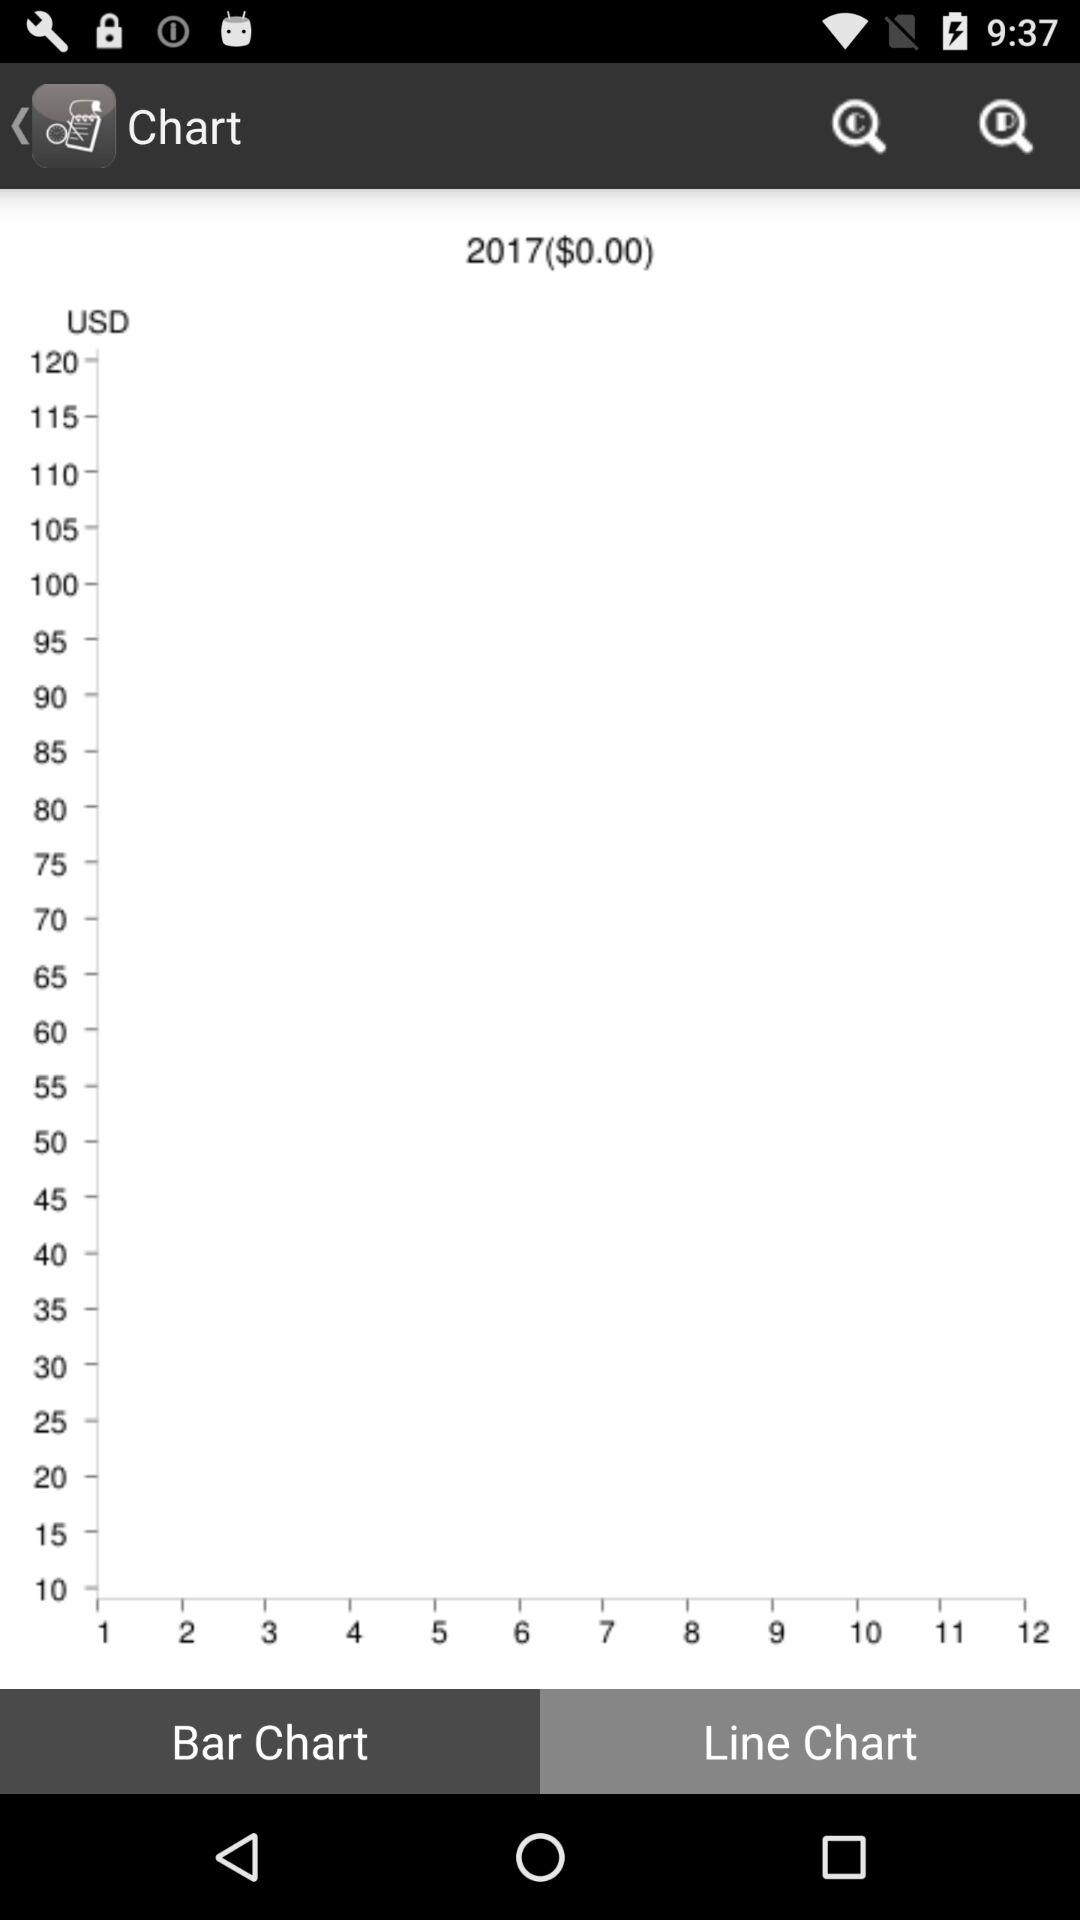What is the mentioned amount? The mentioned amount is $0.00. 